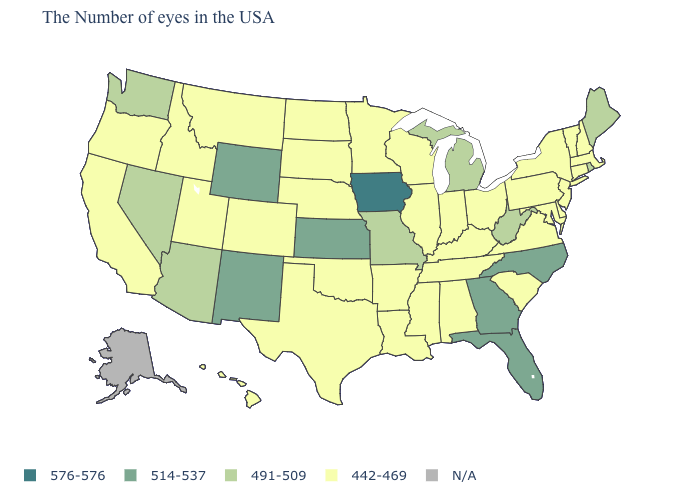What is the lowest value in the USA?
Keep it brief. 442-469. Name the states that have a value in the range 491-509?
Quick response, please. Maine, Rhode Island, West Virginia, Michigan, Missouri, Arizona, Nevada, Washington. What is the value of Minnesota?
Short answer required. 442-469. What is the value of Nebraska?
Give a very brief answer. 442-469. Name the states that have a value in the range 491-509?
Quick response, please. Maine, Rhode Island, West Virginia, Michigan, Missouri, Arizona, Nevada, Washington. Does Maine have the highest value in the Northeast?
Quick response, please. Yes. Name the states that have a value in the range N/A?
Keep it brief. Alaska. Does the map have missing data?
Answer briefly. Yes. What is the lowest value in states that border Wisconsin?
Concise answer only. 442-469. Does New Hampshire have the lowest value in the Northeast?
Short answer required. Yes. What is the value of Idaho?
Answer briefly. 442-469. What is the highest value in the South ?
Concise answer only. 514-537. How many symbols are there in the legend?
Short answer required. 5. Which states have the highest value in the USA?
Keep it brief. Iowa. 